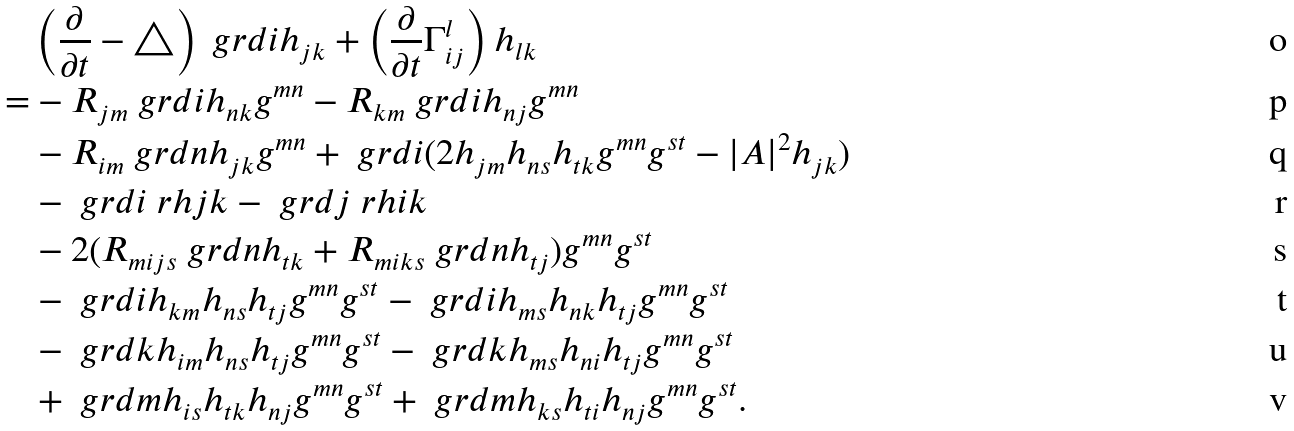Convert formula to latex. <formula><loc_0><loc_0><loc_500><loc_500>& \left ( \frac { \partial } { \partial t } - \triangle \right ) \ g r d { i } h _ { j k } + \left ( \frac { \partial } { \partial t } \Gamma _ { i j } ^ { l } \right ) h _ { l k } \\ = & - R _ { j m } \ g r d { i } h _ { n k } g ^ { m n } - R _ { k m } \ g r d { i } h _ { n j } g ^ { m n } \\ & - R _ { i m } \ g r d { n } h _ { j k } g ^ { m n } + \ g r d { i } ( 2 h _ { j m } h _ { n s } h _ { t k } g ^ { m n } g ^ { s t } - | A | ^ { 2 } h _ { j k } ) \\ & - \ g r d { i } \ r h { j } { k } - \ g r d { j } \ r h { i } { k } \\ & - 2 ( R _ { m i j s } \ g r d { n } h _ { t k } + R _ { m i k s } \ g r d { n } h _ { t j } ) g ^ { m n } g ^ { s t } \\ & - \ g r d { i } h _ { k m } h _ { n s } h _ { t j } g ^ { m n } g ^ { s t } - \ g r d { i } h _ { m s } h _ { n k } h _ { t j } g ^ { m n } g ^ { s t } \\ & - \ g r d { k } h _ { i m } h _ { n s } h _ { t j } g ^ { m n } g ^ { s t } - \ g r d { k } h _ { m s } h _ { n i } h _ { t j } g ^ { m n } g ^ { s t } \\ & + \ g r d { m } h _ { i s } h _ { t k } h _ { n j } g ^ { m n } g ^ { s t } + \ g r d { m } h _ { k s } h _ { t i } h _ { n j } g ^ { m n } g ^ { s t } .</formula> 